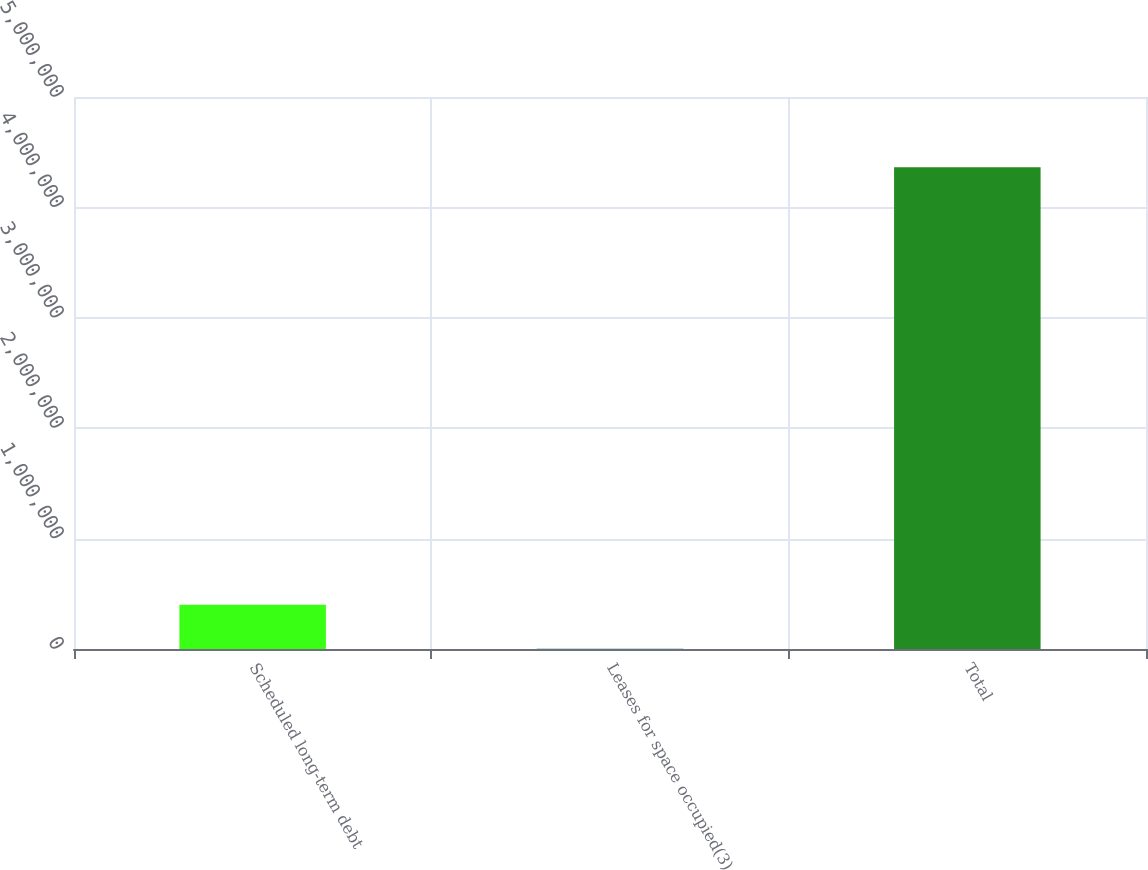Convert chart to OTSL. <chart><loc_0><loc_0><loc_500><loc_500><bar_chart><fcel>Scheduled long-term debt<fcel>Leases for space occupied(3)<fcel>Total<nl><fcel>400053<fcel>1828<fcel>4.36389e+06<nl></chart> 